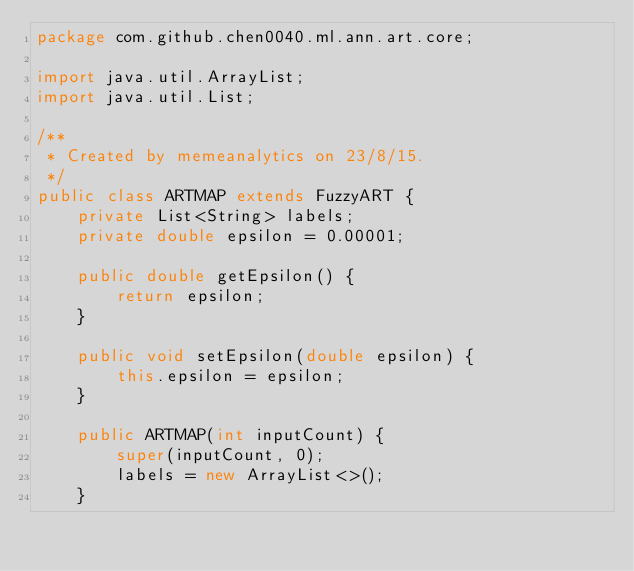<code> <loc_0><loc_0><loc_500><loc_500><_Java_>package com.github.chen0040.ml.ann.art.core;

import java.util.ArrayList;
import java.util.List;

/**
 * Created by memeanalytics on 23/8/15.
 */
public class ARTMAP extends FuzzyART {
    private List<String> labels;
    private double epsilon = 0.00001;

    public double getEpsilon() {
        return epsilon;
    }

    public void setEpsilon(double epsilon) {
        this.epsilon = epsilon;
    }

    public ARTMAP(int inputCount) {
        super(inputCount, 0);
        labels = new ArrayList<>();
    }
</code> 